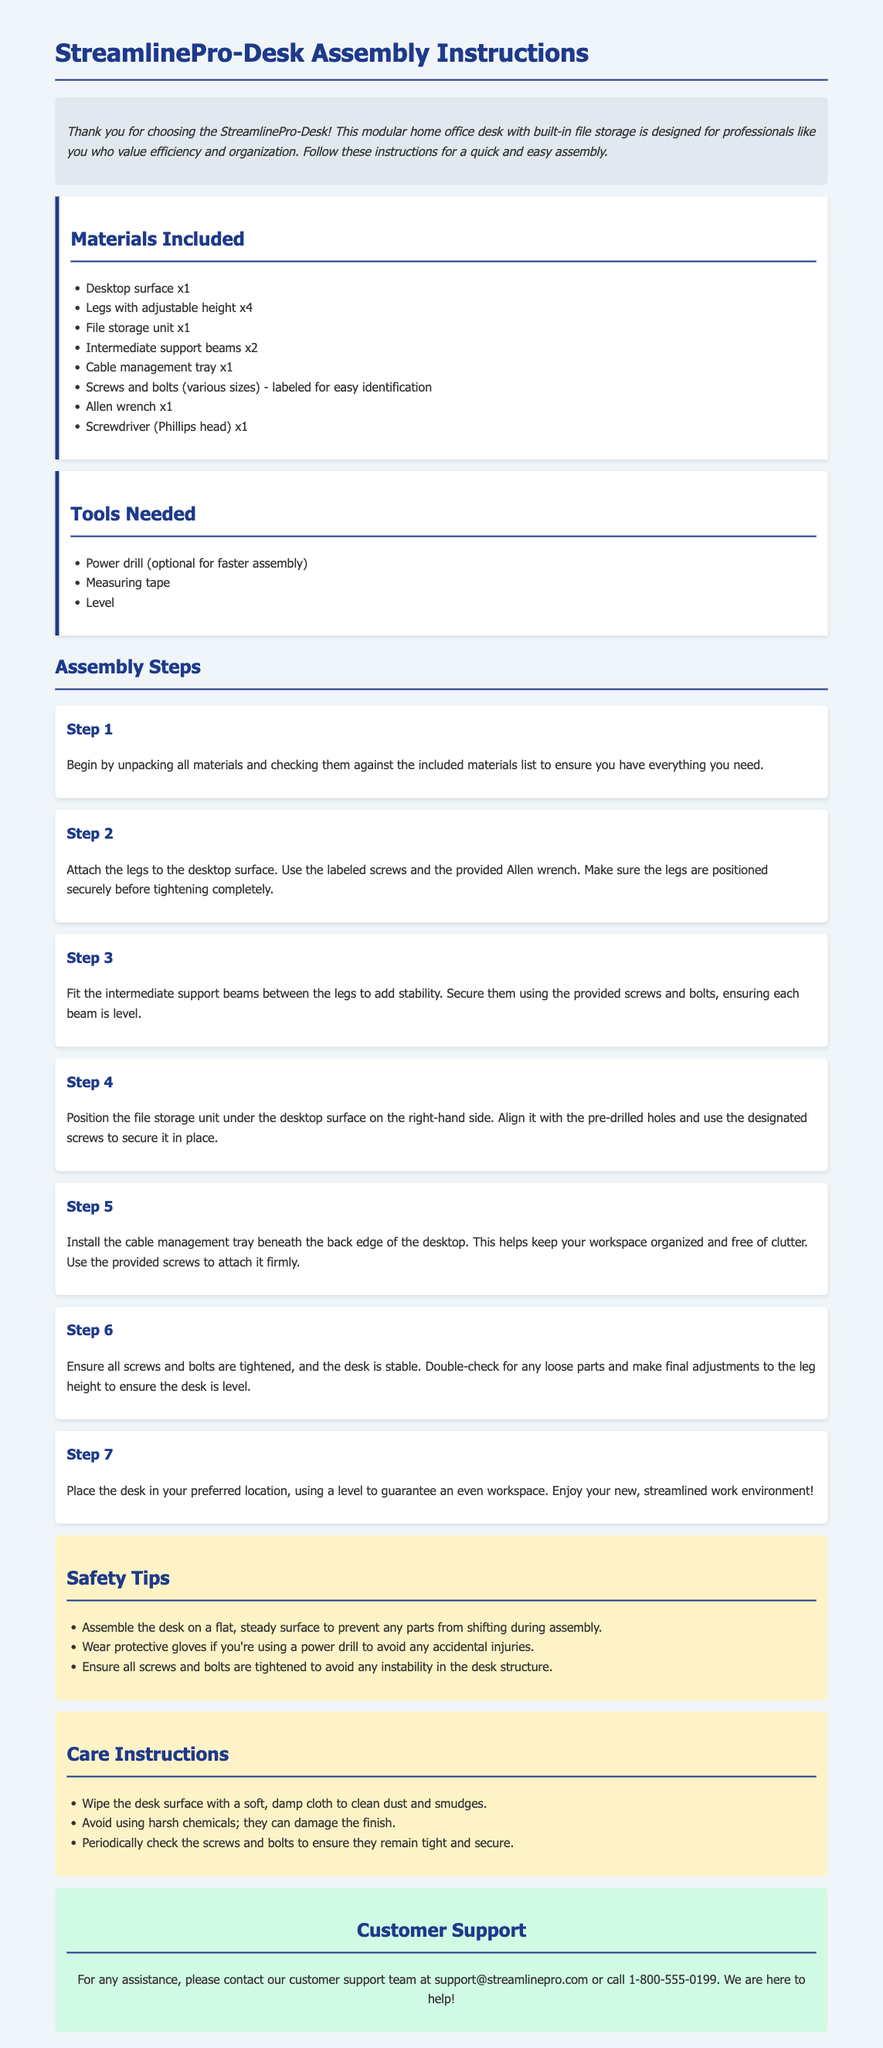What materials are included with the desk? The materials section lists all the components included with the desk.
Answer: Desktop surface x1, Legs with adjustable height x4, File storage unit x1, Intermediate support beams x2, Cable management tray x1, Screws and bolts (various sizes), Allen wrench x1, Screwdriver (Phillips head) x1 How many legs does the desk have? The materials section specifies the number of legs as part of the desk assembly.
Answer: 4 What safety tip is provided for assembly? The safety section lists important tips to ensure safe assembly.
Answer: Assemble the desk on a flat, steady surface Which tool is optional for faster assembly? The tools section identifies tools that can be used during assembly, mentioning which is optional.
Answer: Power drill In which step do you secure the file storage unit? The assembly steps outline when to attach specific components to the desk.
Answer: Step 4 What is the purpose of the cable management tray? The step describing the cable management tray outlines its function in the workspace.
Answer: Keep your workspace organized and free of clutter How do you ensure the desk is level? The last assembly step mentions the method to verify the desk's stability.
Answer: Use a level What is the customer support contact email? The customer support section provides the contact information for assistance.
Answer: support@streamlinepro.com 